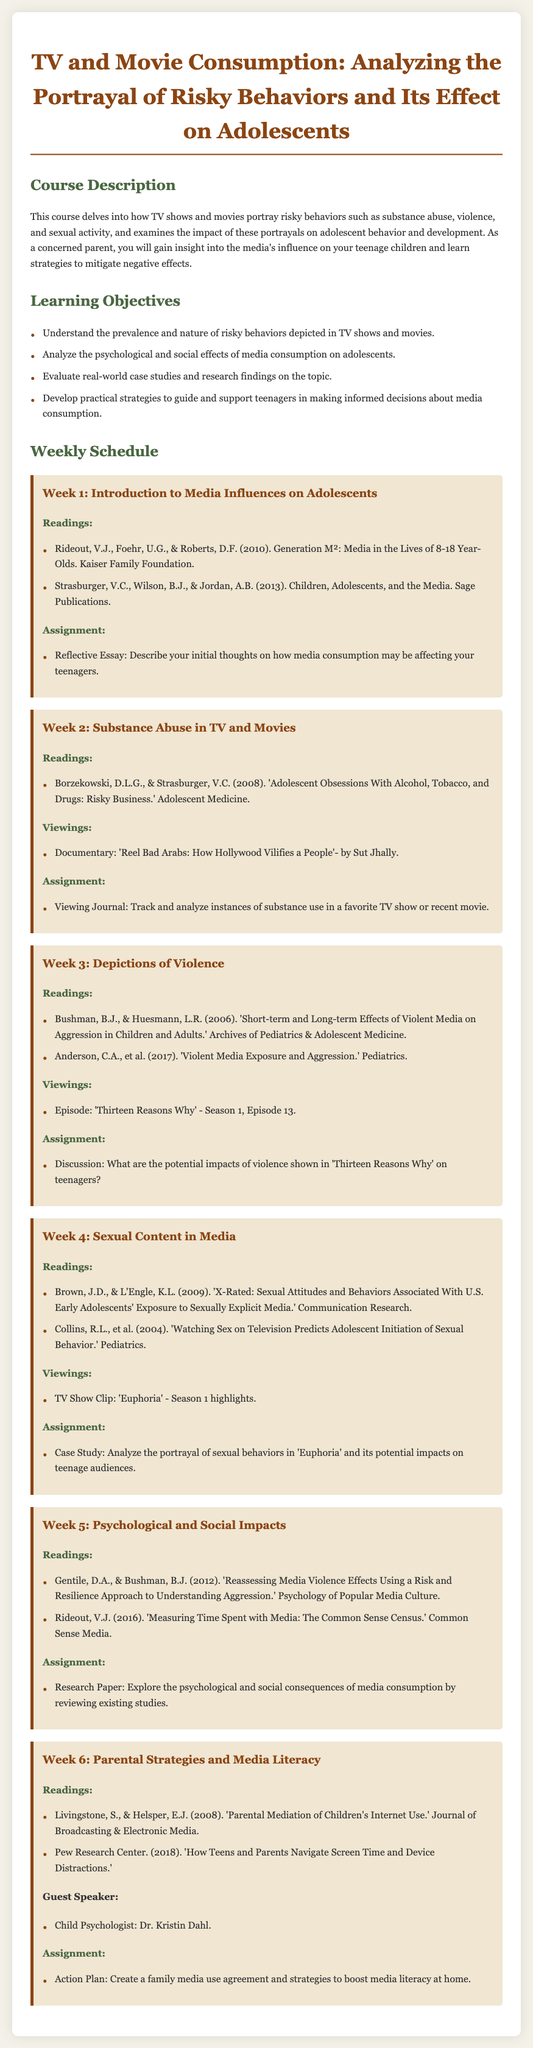What is the course title? The course title is specified at the top of the document.
Answer: TV and Movie Consumption: Analyzing the Portrayal of Risky Behaviors and Its Effect on Adolescents Who is one of the guest speakers? The guest speaker is listed in the course schedule for Week 6.
Answer: Dr. Kristin Dahl What is the main focus of Week 2? Week 2 focuses on a specific topic related to risky behaviors portrayed in media.
Answer: Substance Abuse in TV and Movies What is one of the readings for Week 4? A reading is identified under the Week 4 section, focusing on sexual content.
Answer: Brown, J.D., & L'Engle, K.L. (2009) How many weeks are there in the course? The document outlines the schedule for each week of the course.
Answer: Six weeks What type of essay is assigned in Week 1? The assignment in Week 1 requires a particular format of writing.
Answer: Reflective Essay What is one objective of the course? An objective of the course is listed in the Learning Objectives section.
Answer: Evaluate real-world case studies and research findings on the topic Which episode of 'Thirteen Reasons Why' is mentioned? The specific episode is included in Week 3's viewing section.
Answer: Season 1, Episode 13 What is the theme of Week 3? The overall theme for Week 3 is described in the title of that week.
Answer: Depictions of Violence 